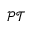<formula> <loc_0><loc_0><loc_500><loc_500>\mathcal { P T }</formula> 